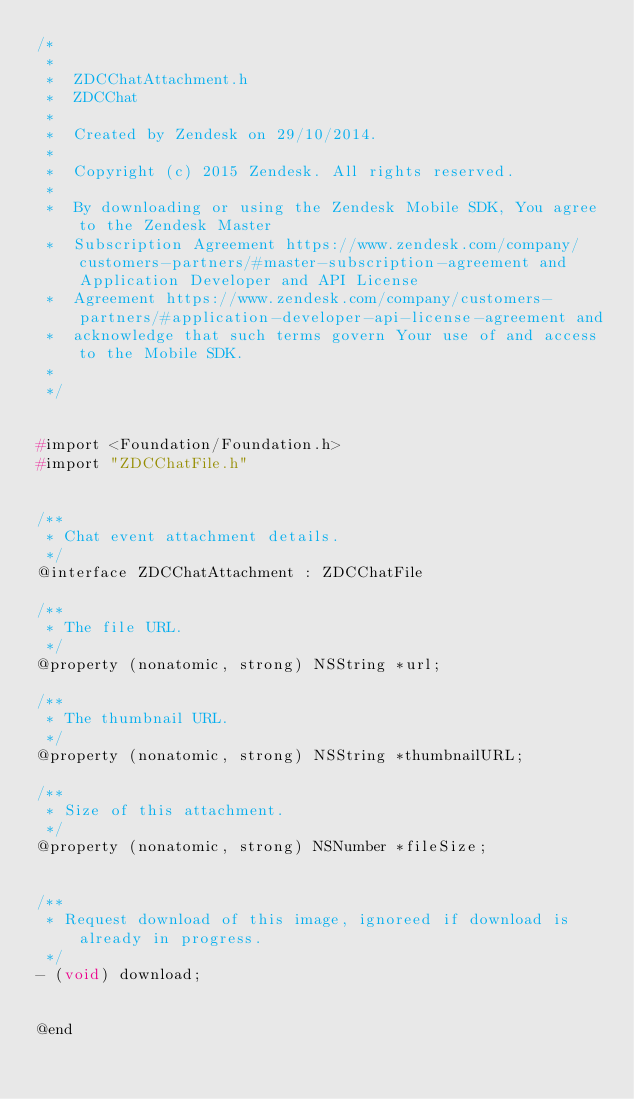Convert code to text. <code><loc_0><loc_0><loc_500><loc_500><_C_>/*
 *
 *  ZDCChatAttachment.h
 *  ZDCChat
 *
 *  Created by Zendesk on 29/10/2014.
 *
 *  Copyright (c) 2015 Zendesk. All rights reserved.
 *
 *  By downloading or using the Zendesk Mobile SDK, You agree to the Zendesk Master
 *  Subscription Agreement https://www.zendesk.com/company/customers-partners/#master-subscription-agreement and Application Developer and API License
 *  Agreement https://www.zendesk.com/company/customers-partners/#application-developer-api-license-agreement and
 *  acknowledge that such terms govern Your use of and access to the Mobile SDK.
 *
 */


#import <Foundation/Foundation.h>
#import "ZDCChatFile.h"


/**
 * Chat event attachment details.
 */
@interface ZDCChatAttachment : ZDCChatFile

/**
 * The file URL.
 */
@property (nonatomic, strong) NSString *url;

/**
 * The thumbnail URL.
 */
@property (nonatomic, strong) NSString *thumbnailURL;

/**
 * Size of this attachment.
 */
@property (nonatomic, strong) NSNumber *fileSize;


/**
 * Request download of this image, ignoreed if download is already in progress.
 */
- (void) download;


@end

</code> 